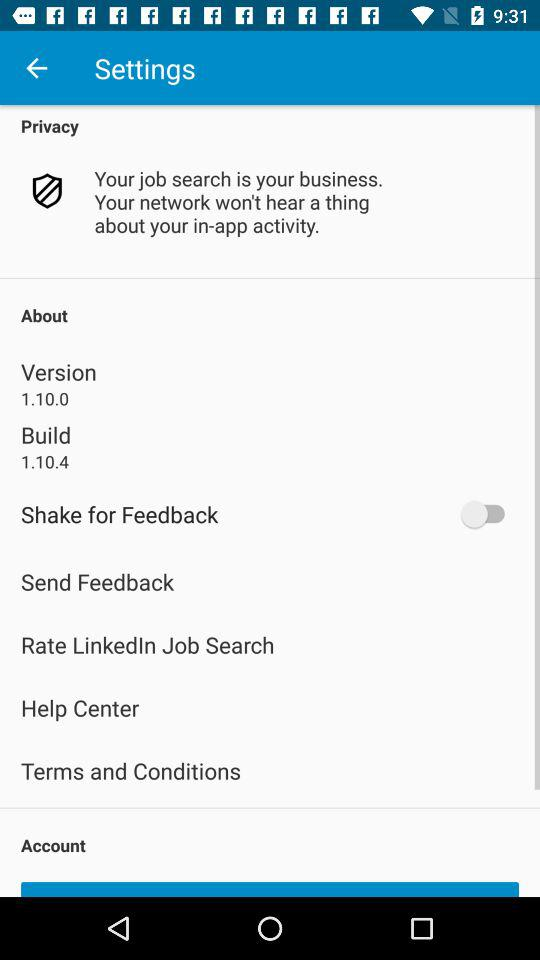What is the status of "Shake for Feedback"? The status is "off". 